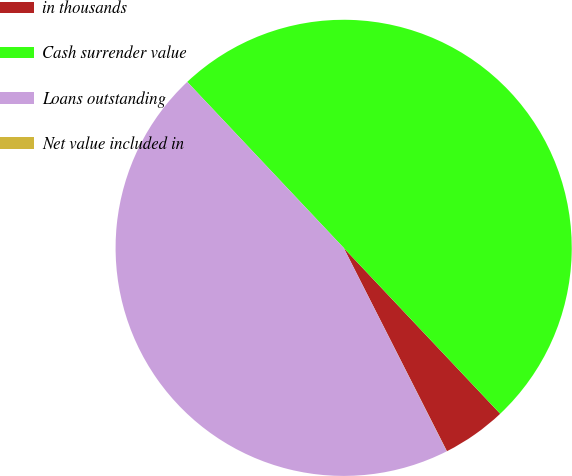Convert chart to OTSL. <chart><loc_0><loc_0><loc_500><loc_500><pie_chart><fcel>in thousands<fcel>Cash surrender value<fcel>Loans outstanding<fcel>Net value included in<nl><fcel>4.56%<fcel>49.99%<fcel>45.44%<fcel>0.01%<nl></chart> 